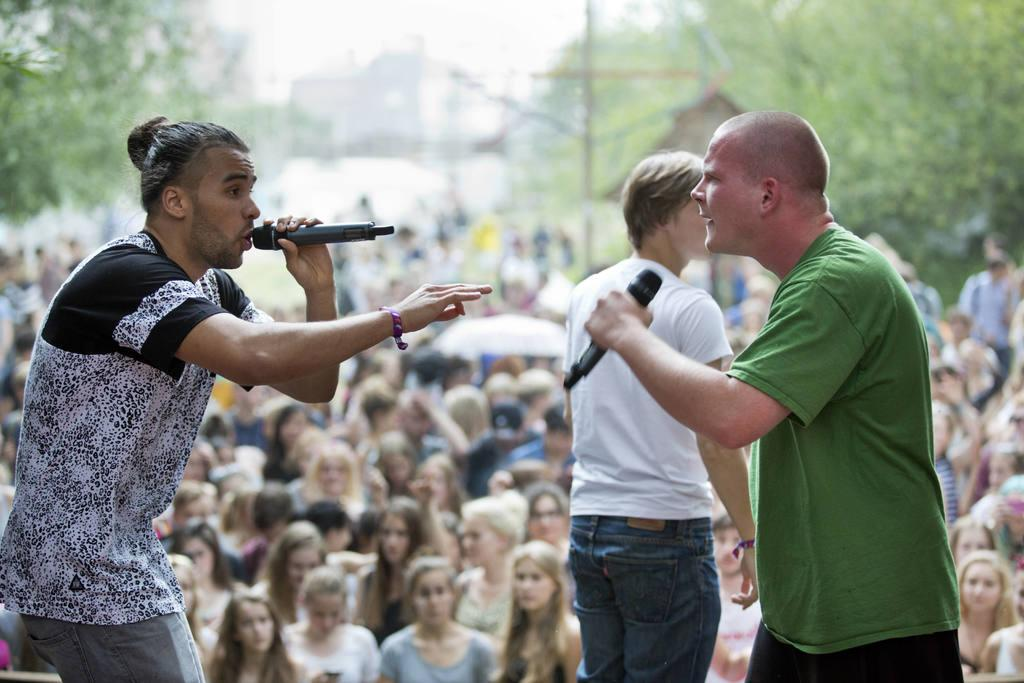How many people are standing in the image? There are three people standing in the image. What are two of the people holding? Two of the people are holding microphones. Can you describe the background of the image? There are people and trees visible in the background of the image, and the background appears blurred. What type of apple is being juggled by the people in the image? There is no apple present in the image, nor are the people juggling anything. 